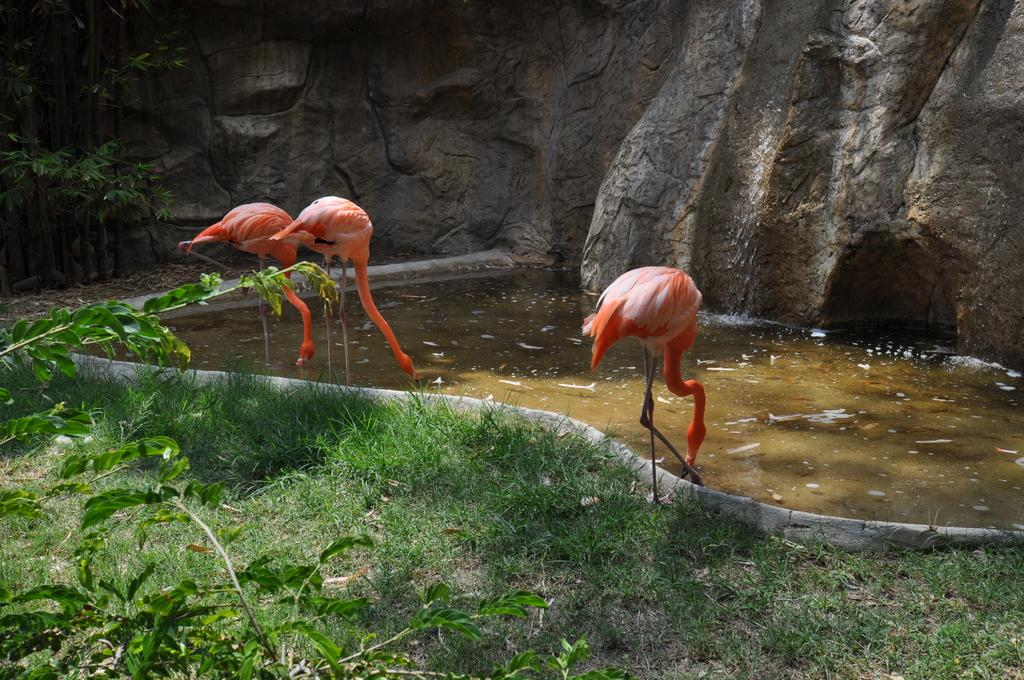What type of vegetation can be seen in the image? There is grass in the image. What geographical feature is present in the image? There is a hill in the image. What natural element is visible in the image? There is water visible in the image. What type of birds are in the image? There are orange-colored cranes in the image. What type of insect can be seen flying over the hill in the image? There is no insect visible in the image; it only features grass, a hill, water, and orange-colored cranes. What type of pleasure activity is taking place in the image? There is no indication of any pleasure activity taking place in the image. --- 